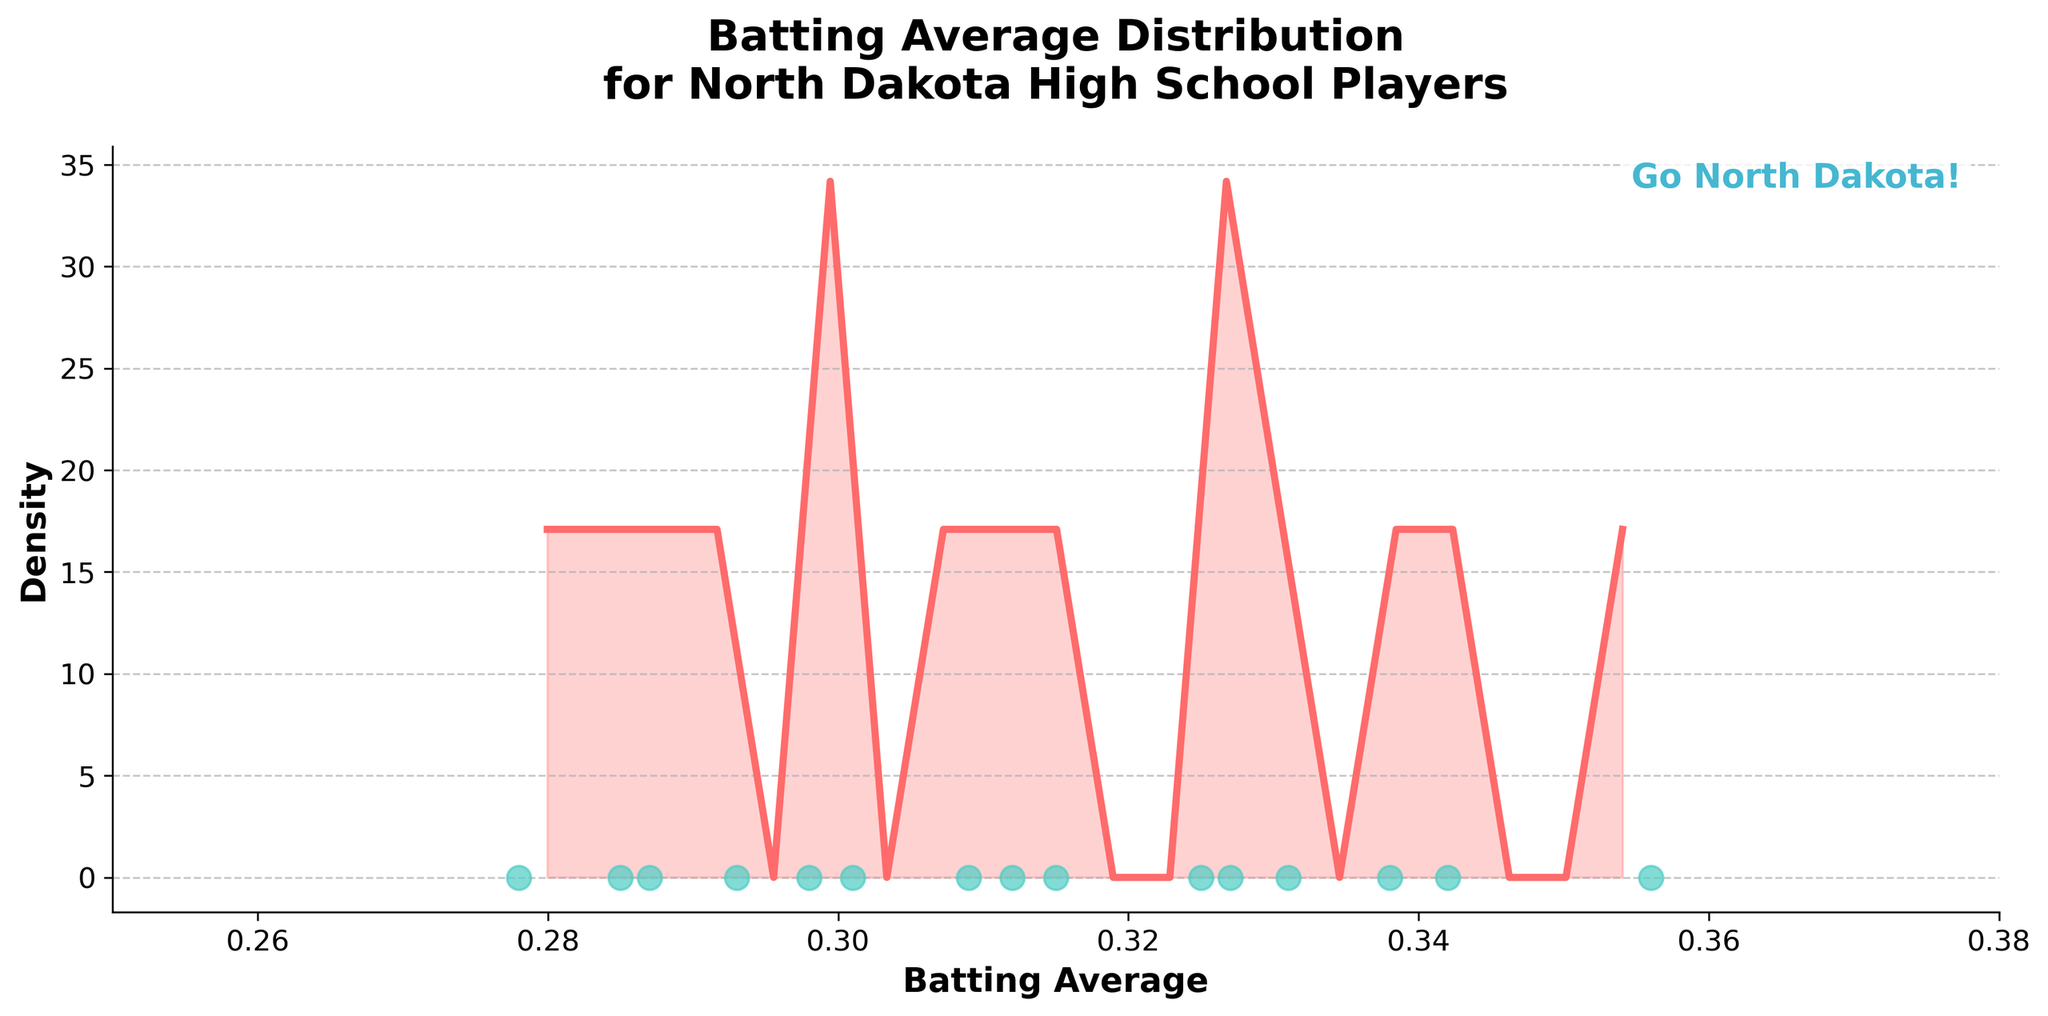What is the title of the plot? The title of the plot is displayed at the top of the figure. It reads "Batting Average Distribution for North Dakota High School Players".
Answer: Batting Average Distribution for North Dakota High School Players What are the limits of the x-axis? The x-axis represents the batting average and its limits can be observed at the ends of the axis. It ranges from 0.25 to 0.38.
Answer: 0.25 to 0.38 How many individual data points are shown in the scatter plot? Each data point in the scatter plot represents a player's batting average. By counting these, we can see there are 15 data points.
Answer: 15 Which color is used for the density curve? The density curve is the line that follows the distribution of the data. It is colored in a bright, noticeable shade.
Answer: Red Is there any text annotation in the plot? If so, what does it say? The plot includes a text annotation located towards the top-right corner which provides an additional message. It says "Go North Dakota!".
Answer: Go North Dakota! What is the approximate highest density value and what does it represent? The highest point on the density curve indicates the highest density value. By looking at the y-axis, we can approximate this value. It represents the batting average with the highest frequency.
Answer: ~10 What does the shape of the density curve indicate about the distribution of batting averages? The shape of the density curve illustrates the distribution of batting averages. A higher peak indicates more players have averages near that value, whereas lower regions suggest fewer players at those averages.
Answer: Bimodal distribution Which batting average has the highest frequency of occurrence? The highest frequency of occurrence is at the peak of the density curve. This peak occurs around a specific batting average value, suggesting most players have this average.
Answer: ~0.325 How do the individual data points spread along the x-axis relative to the density curve? The individual data points, shown as green dots along the x-axis, align with the shape of the density curve, indicating that the peaks of the curve correspond to more densely packed points.
Answer: Aligned with curve What trend can you observe on the density curve from 0.25 to 0.38? Observing the density curve from the start to end of the x-axis, we can note it rises to a peak, dips, rises again to another peak, and then drops, indicating two common batting average ranges.
Answer: Bimodal trend 